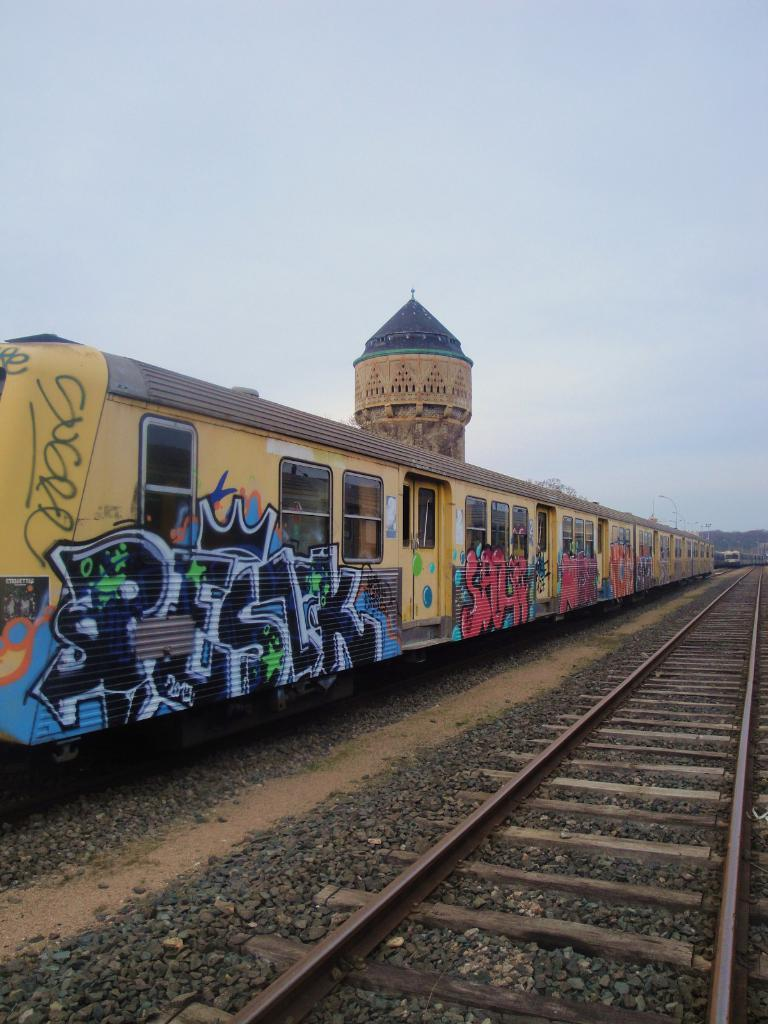What type of vehicles can be seen in the image? There are trains in the image. What is the path that the trains are following? There is a railway track in the image. What can be seen in the background of the image? There is a building and electric poles in the background of the image. What is visible in the sky in the image? The sky is visible in the background of the image. What type of recess is available for the son in the image? There is no son or recess present in the image. Is there a fire visible in the image? There is no fire visible in the image. 